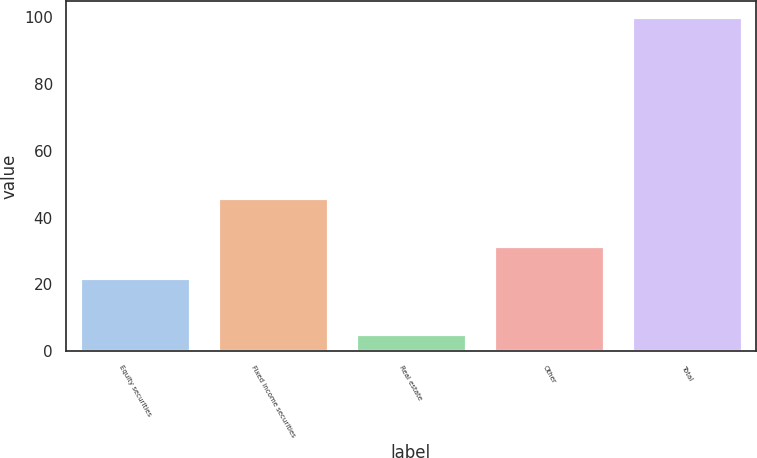Convert chart. <chart><loc_0><loc_0><loc_500><loc_500><bar_chart><fcel>Equity securities<fcel>Fixed income securities<fcel>Real estate<fcel>Other<fcel>Total<nl><fcel>22<fcel>46<fcel>5<fcel>31.5<fcel>100<nl></chart> 